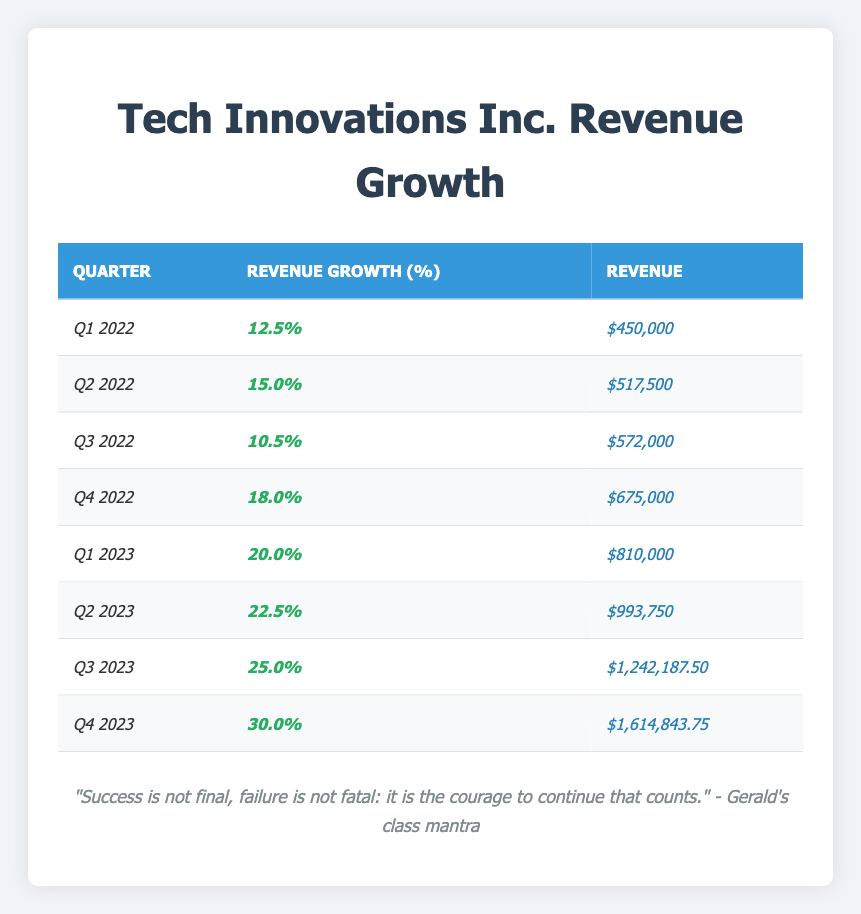What was the revenue for Q2 2023? The table shows the revenue for Q2 2023 as $993,750.
Answer: $993,750 What is the revenue growth percentage for Q4 2022? According to the table, the revenue growth percentage for Q4 2022 is 18.0%.
Answer: 18.0% What were the total revenues for the four quarters of 2022? The total revenue for 2022 can be calculated by adding the revenues for each quarter: $450,000 + $517,500 + $572,000 + $675,000 = $2,214,500.
Answer: $2,214,500 Which quarter had the highest revenue growth percentage in 2023? By comparing the revenue growth percentages listed for 2023, Q4 2023 has the highest at 30.0%.
Answer: Q4 2023 What was the revenue for Q3 2022? The table indicates the revenue for Q3 2022 is $572,000.
Answer: $572,000 What is the average revenue growth percentage for 2022? The average is calculated by averaging the percentages for the four quarters of 2022: (12.5 + 15.0 + 10.5 + 18.0) / 4 = 14.03%.
Answer: 14.03% Did Tech Innovations Inc. experience an increase in revenue growth from Q3 2022 to Q1 2023? Checking the table shows that revenue growth increased from 10.5% in Q3 2022 to 20.0% in Q1 2023, confirming an increase.
Answer: Yes What was the percentage increase in revenue from Q1 2022 to Q1 2023? To find the percentage increase, subtract 450,000 from 810,000, resulting in a change of 360,000. Then divide by 450,000: (360,000 / 450,000) * 100 = 80%.
Answer: 80% Which quarter showed the largest absolute revenue figure? Looking at the table, Q4 2023 has the largest revenue figure of $1,614,843.75.
Answer: Q4 2023 What was the revenue growth percentage for Q1 2023 compared to the previous quarter? The revenue growth from Q4 2022 to Q1 2023 can be calculated as follows: ((810,000 - 675,000) / 675,000) * 100 = 19.88%.
Answer: 19.88% 